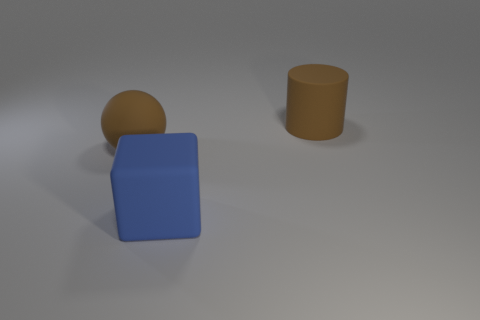The ball in front of the brown thing that is on the right side of the big blue thing to the left of the cylinder is what color?
Offer a very short reply. Brown. Is the number of brown balls that are to the right of the large ball the same as the number of spheres behind the brown rubber cylinder?
Your response must be concise. Yes. What shape is the brown rubber thing that is the same size as the rubber ball?
Offer a very short reply. Cylinder. Is there a big matte cylinder that has the same color as the large sphere?
Make the answer very short. Yes. There is a brown rubber thing on the left side of the large brown cylinder; what is its shape?
Offer a terse response. Sphere. What color is the large rubber cube?
Offer a terse response. Blue. There is a cylinder that is the same material as the ball; what color is it?
Keep it short and to the point. Brown. How many brown objects are made of the same material as the large cube?
Offer a terse response. 2. What number of blue matte cubes are in front of the brown rubber cylinder?
Offer a very short reply. 1. Are there more brown matte cylinders to the right of the big blue cube than big matte cubes that are behind the ball?
Keep it short and to the point. Yes. 